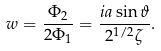Convert formula to latex. <formula><loc_0><loc_0><loc_500><loc_500>w = \frac { \Phi _ { 2 } } { 2 \Phi _ { 1 } } = \frac { i a \sin \vartheta } { 2 ^ { 1 / 2 } \zeta } .</formula> 